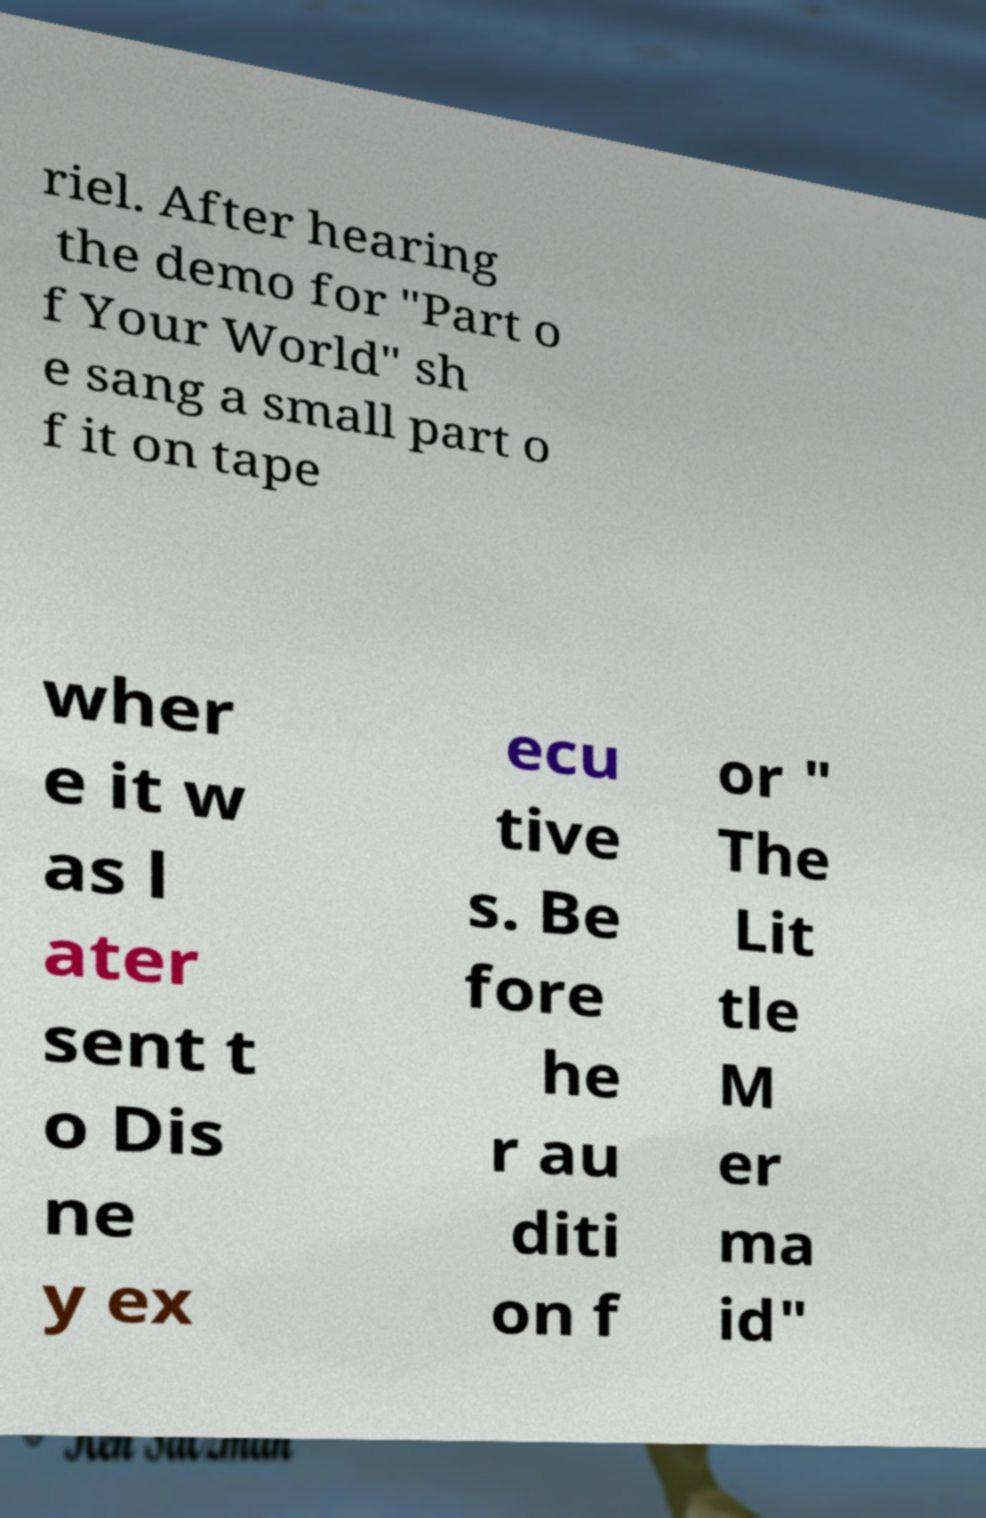Can you read and provide the text displayed in the image?This photo seems to have some interesting text. Can you extract and type it out for me? riel. After hearing the demo for "Part o f Your World" sh e sang a small part o f it on tape wher e it w as l ater sent t o Dis ne y ex ecu tive s. Be fore he r au diti on f or " The Lit tle M er ma id" 